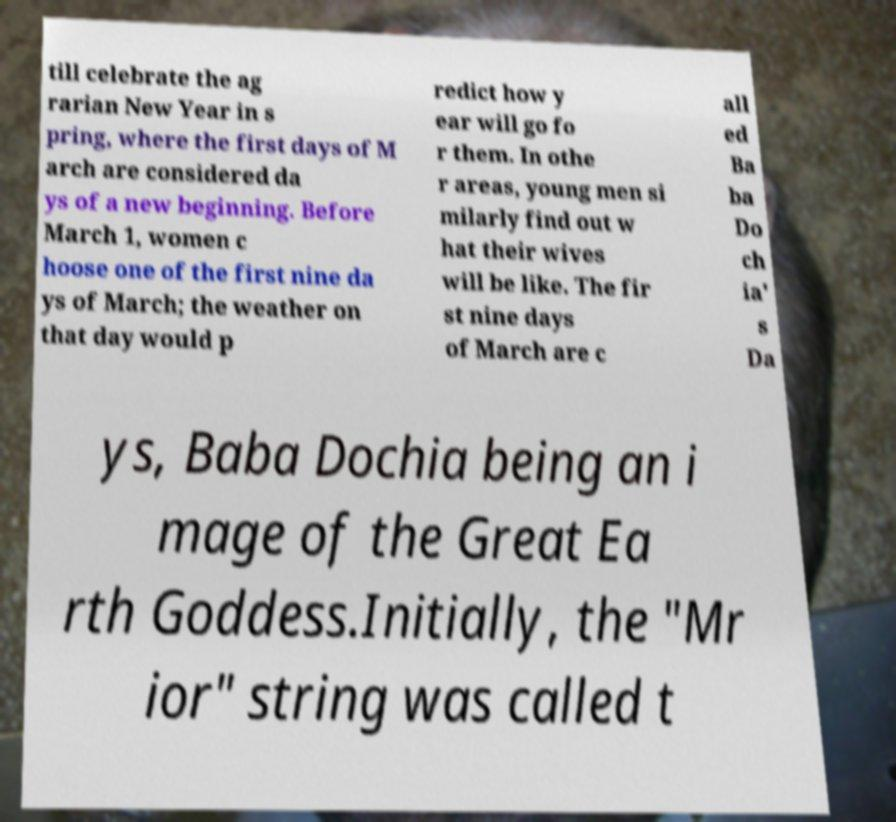What messages or text are displayed in this image? I need them in a readable, typed format. till celebrate the ag rarian New Year in s pring, where the first days of M arch are considered da ys of a new beginning. Before March 1, women c hoose one of the first nine da ys of March; the weather on that day would p redict how y ear will go fo r them. In othe r areas, young men si milarly find out w hat their wives will be like. The fir st nine days of March are c all ed Ba ba Do ch ia' s Da ys, Baba Dochia being an i mage of the Great Ea rth Goddess.Initially, the "Mr ior" string was called t 